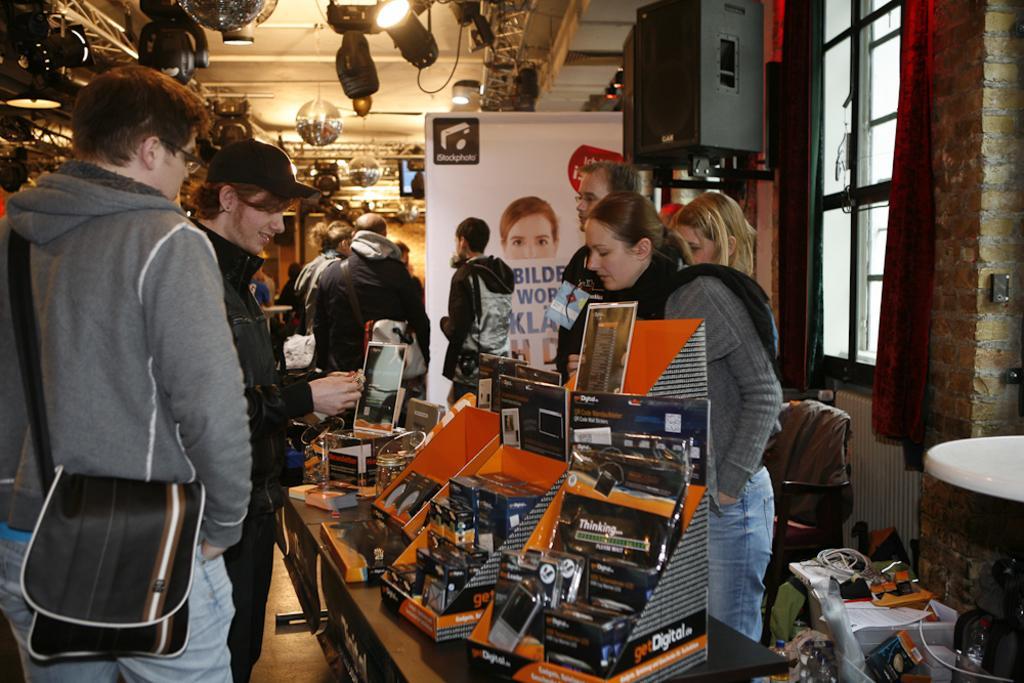In one or two sentences, can you explain what this image depicts? In this image I can see there are group of people who are standing on the floor. Here we have few products on a table. On the right side we have a window. 